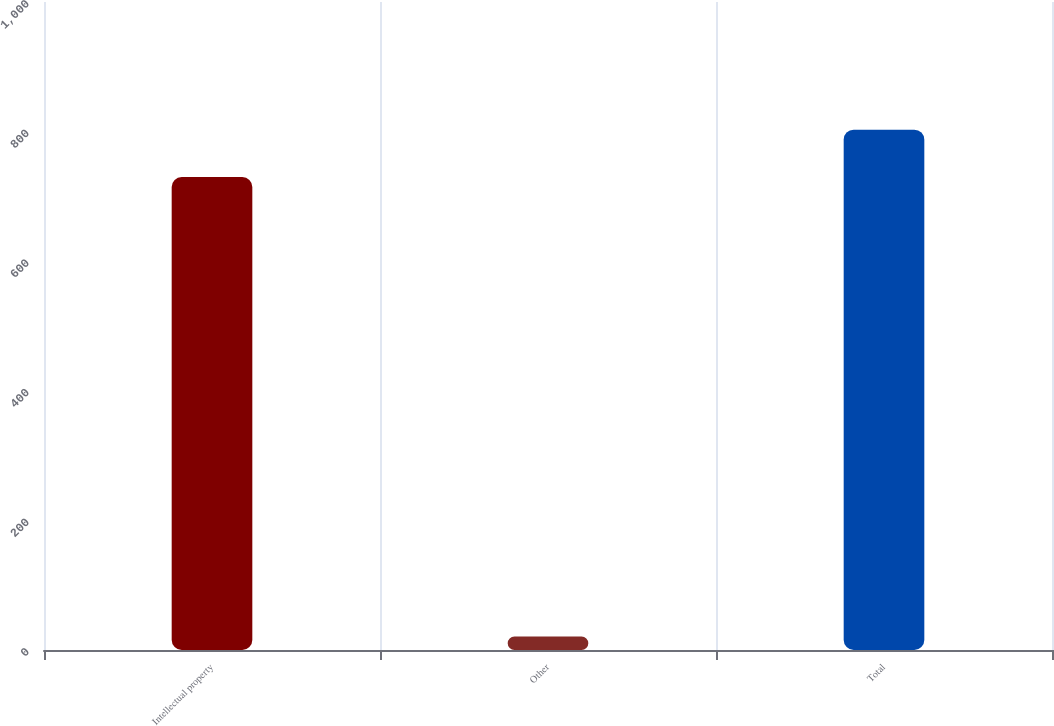Convert chart. <chart><loc_0><loc_0><loc_500><loc_500><bar_chart><fcel>Intellectual property<fcel>Other<fcel>Total<nl><fcel>730<fcel>21<fcel>803<nl></chart> 